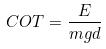<formula> <loc_0><loc_0><loc_500><loc_500>C O T = \frac { E } { m g d }</formula> 